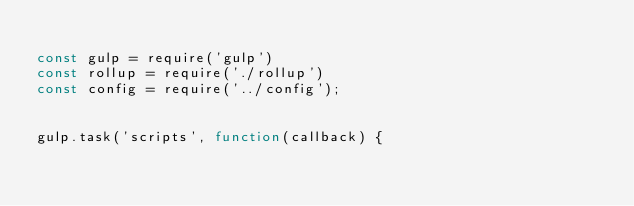<code> <loc_0><loc_0><loc_500><loc_500><_JavaScript_>
const gulp = require('gulp')
const rollup = require('./rollup')
const config = require('../config');


gulp.task('scripts', function(callback) {</code> 